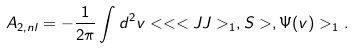Convert formula to latex. <formula><loc_0><loc_0><loc_500><loc_500>A _ { 2 , n l } = - \frac { 1 } { 2 \pi } \int d ^ { 2 } v < < < J J > _ { 1 } , S > , \Psi ( v ) > _ { 1 } .</formula> 